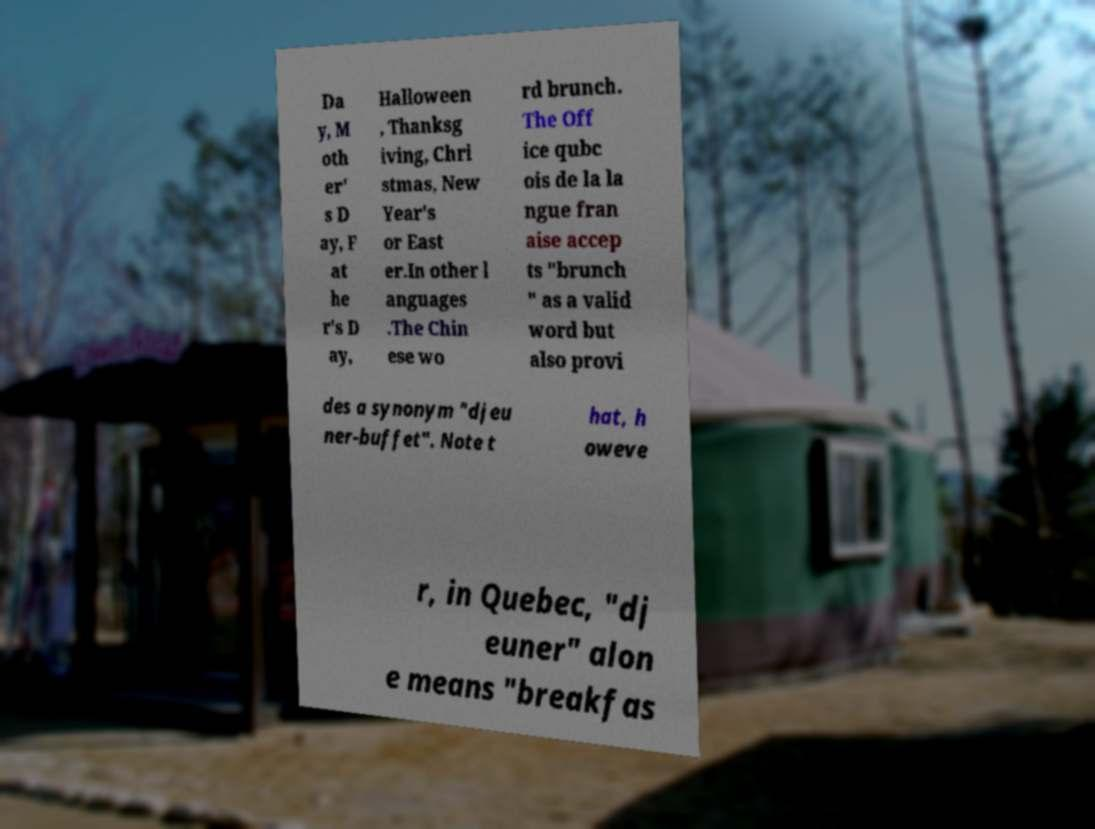Can you accurately transcribe the text from the provided image for me? Da y, M oth er' s D ay, F at he r's D ay, Halloween , Thanksg iving, Chri stmas, New Year's or East er.In other l anguages .The Chin ese wo rd brunch. The Off ice qubc ois de la la ngue fran aise accep ts "brunch " as a valid word but also provi des a synonym "djeu ner-buffet". Note t hat, h oweve r, in Quebec, "dj euner" alon e means "breakfas 